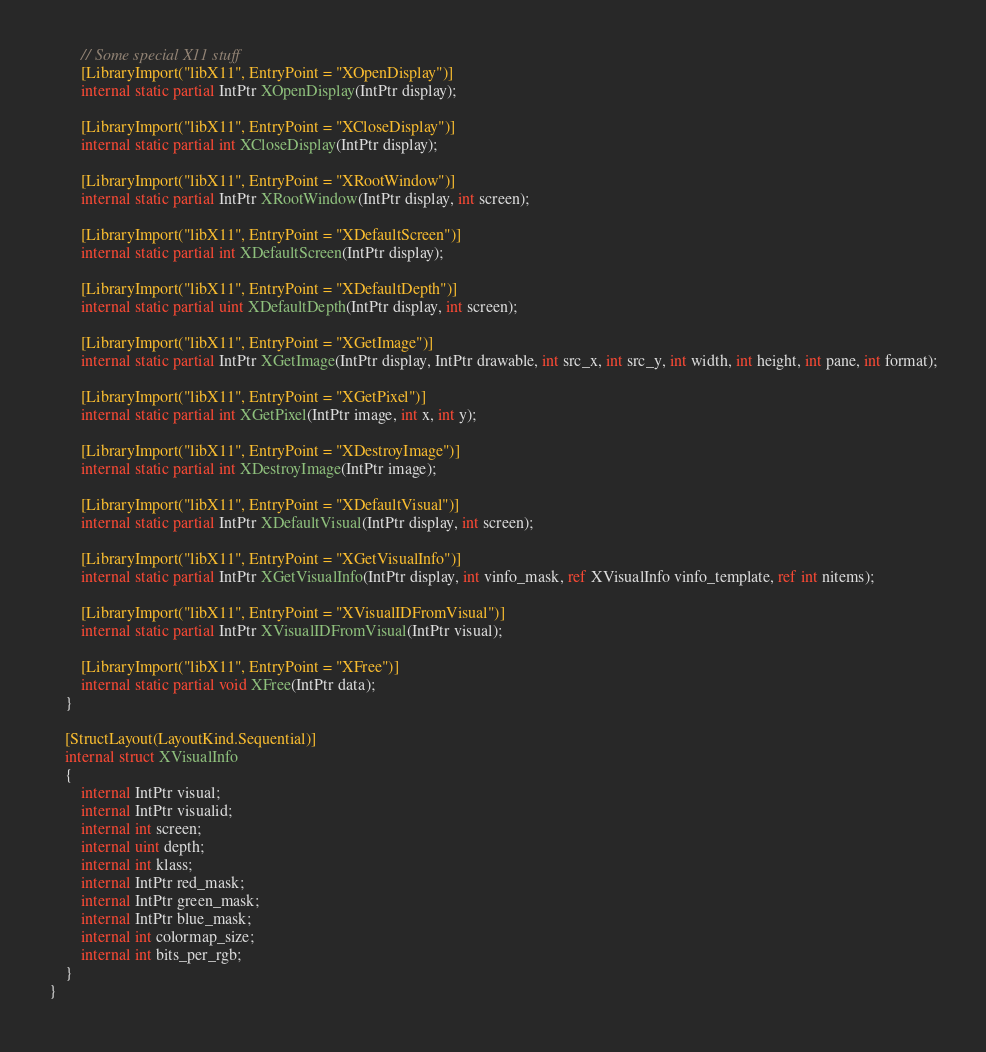<code> <loc_0><loc_0><loc_500><loc_500><_C#_>        // Some special X11 stuff
        [LibraryImport("libX11", EntryPoint = "XOpenDisplay")]
        internal static partial IntPtr XOpenDisplay(IntPtr display);

        [LibraryImport("libX11", EntryPoint = "XCloseDisplay")]
        internal static partial int XCloseDisplay(IntPtr display);

        [LibraryImport("libX11", EntryPoint = "XRootWindow")]
        internal static partial IntPtr XRootWindow(IntPtr display, int screen);

        [LibraryImport("libX11", EntryPoint = "XDefaultScreen")]
        internal static partial int XDefaultScreen(IntPtr display);

        [LibraryImport("libX11", EntryPoint = "XDefaultDepth")]
        internal static partial uint XDefaultDepth(IntPtr display, int screen);

        [LibraryImport("libX11", EntryPoint = "XGetImage")]
        internal static partial IntPtr XGetImage(IntPtr display, IntPtr drawable, int src_x, int src_y, int width, int height, int pane, int format);

        [LibraryImport("libX11", EntryPoint = "XGetPixel")]
        internal static partial int XGetPixel(IntPtr image, int x, int y);

        [LibraryImport("libX11", EntryPoint = "XDestroyImage")]
        internal static partial int XDestroyImage(IntPtr image);

        [LibraryImport("libX11", EntryPoint = "XDefaultVisual")]
        internal static partial IntPtr XDefaultVisual(IntPtr display, int screen);

        [LibraryImport("libX11", EntryPoint = "XGetVisualInfo")]
        internal static partial IntPtr XGetVisualInfo(IntPtr display, int vinfo_mask, ref XVisualInfo vinfo_template, ref int nitems);

        [LibraryImport("libX11", EntryPoint = "XVisualIDFromVisual")]
        internal static partial IntPtr XVisualIDFromVisual(IntPtr visual);

        [LibraryImport("libX11", EntryPoint = "XFree")]
        internal static partial void XFree(IntPtr data);
    }

    [StructLayout(LayoutKind.Sequential)]
    internal struct XVisualInfo
    {
        internal IntPtr visual;
        internal IntPtr visualid;
        internal int screen;
        internal uint depth;
        internal int klass;
        internal IntPtr red_mask;
        internal IntPtr green_mask;
        internal IntPtr blue_mask;
        internal int colormap_size;
        internal int bits_per_rgb;
    }
}
</code> 